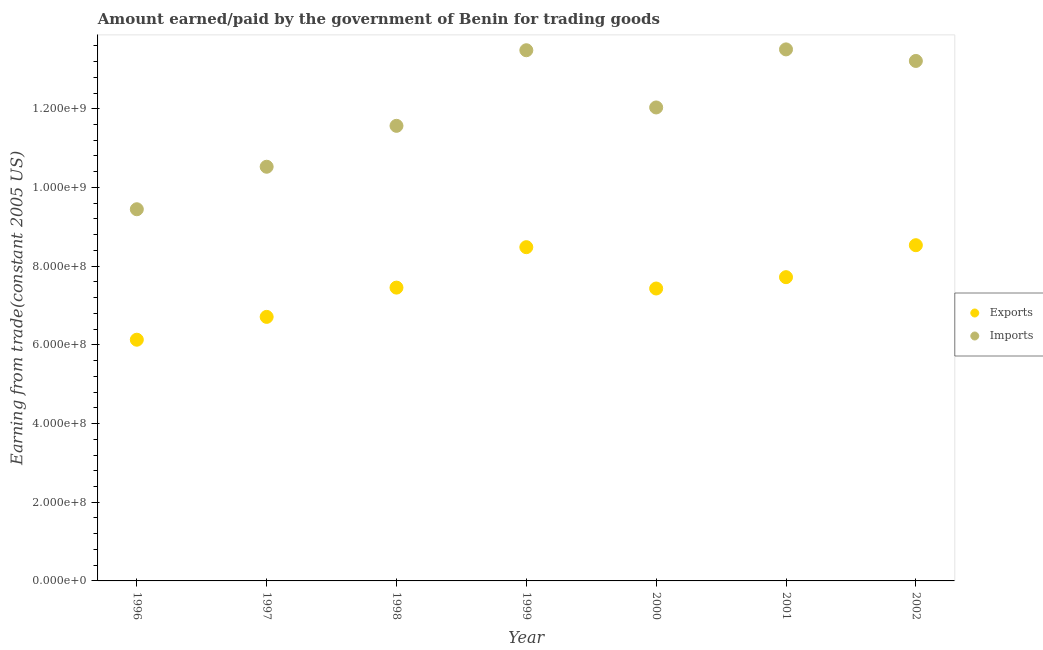How many different coloured dotlines are there?
Keep it short and to the point. 2. What is the amount earned from exports in 2000?
Ensure brevity in your answer.  7.43e+08. Across all years, what is the maximum amount earned from exports?
Provide a short and direct response. 8.53e+08. Across all years, what is the minimum amount paid for imports?
Your response must be concise. 9.45e+08. In which year was the amount earned from exports maximum?
Make the answer very short. 2002. In which year was the amount paid for imports minimum?
Keep it short and to the point. 1996. What is the total amount earned from exports in the graph?
Offer a terse response. 5.25e+09. What is the difference between the amount earned from exports in 2000 and that in 2002?
Ensure brevity in your answer.  -1.10e+08. What is the difference between the amount earned from exports in 2001 and the amount paid for imports in 2002?
Offer a very short reply. -5.50e+08. What is the average amount paid for imports per year?
Offer a very short reply. 1.20e+09. In the year 2001, what is the difference between the amount paid for imports and amount earned from exports?
Your answer should be very brief. 5.79e+08. What is the ratio of the amount paid for imports in 1996 to that in 2000?
Your response must be concise. 0.79. Is the difference between the amount paid for imports in 1996 and 2000 greater than the difference between the amount earned from exports in 1996 and 2000?
Give a very brief answer. No. What is the difference between the highest and the second highest amount paid for imports?
Ensure brevity in your answer.  2.15e+06. What is the difference between the highest and the lowest amount paid for imports?
Make the answer very short. 4.06e+08. How many dotlines are there?
Provide a short and direct response. 2. What is the difference between two consecutive major ticks on the Y-axis?
Your response must be concise. 2.00e+08. Are the values on the major ticks of Y-axis written in scientific E-notation?
Provide a short and direct response. Yes. Does the graph contain grids?
Offer a very short reply. No. How many legend labels are there?
Your response must be concise. 2. What is the title of the graph?
Give a very brief answer. Amount earned/paid by the government of Benin for trading goods. What is the label or title of the Y-axis?
Make the answer very short. Earning from trade(constant 2005 US). What is the Earning from trade(constant 2005 US) in Exports in 1996?
Give a very brief answer. 6.13e+08. What is the Earning from trade(constant 2005 US) in Imports in 1996?
Make the answer very short. 9.45e+08. What is the Earning from trade(constant 2005 US) of Exports in 1997?
Offer a very short reply. 6.71e+08. What is the Earning from trade(constant 2005 US) in Imports in 1997?
Make the answer very short. 1.05e+09. What is the Earning from trade(constant 2005 US) in Exports in 1998?
Ensure brevity in your answer.  7.45e+08. What is the Earning from trade(constant 2005 US) of Imports in 1998?
Your answer should be compact. 1.16e+09. What is the Earning from trade(constant 2005 US) in Exports in 1999?
Make the answer very short. 8.48e+08. What is the Earning from trade(constant 2005 US) in Imports in 1999?
Your response must be concise. 1.35e+09. What is the Earning from trade(constant 2005 US) in Exports in 2000?
Offer a very short reply. 7.43e+08. What is the Earning from trade(constant 2005 US) of Imports in 2000?
Your response must be concise. 1.20e+09. What is the Earning from trade(constant 2005 US) of Exports in 2001?
Keep it short and to the point. 7.72e+08. What is the Earning from trade(constant 2005 US) in Imports in 2001?
Give a very brief answer. 1.35e+09. What is the Earning from trade(constant 2005 US) in Exports in 2002?
Provide a succinct answer. 8.53e+08. What is the Earning from trade(constant 2005 US) in Imports in 2002?
Provide a succinct answer. 1.32e+09. Across all years, what is the maximum Earning from trade(constant 2005 US) in Exports?
Keep it short and to the point. 8.53e+08. Across all years, what is the maximum Earning from trade(constant 2005 US) in Imports?
Your response must be concise. 1.35e+09. Across all years, what is the minimum Earning from trade(constant 2005 US) of Exports?
Keep it short and to the point. 6.13e+08. Across all years, what is the minimum Earning from trade(constant 2005 US) of Imports?
Your answer should be compact. 9.45e+08. What is the total Earning from trade(constant 2005 US) of Exports in the graph?
Your answer should be compact. 5.25e+09. What is the total Earning from trade(constant 2005 US) in Imports in the graph?
Ensure brevity in your answer.  8.38e+09. What is the difference between the Earning from trade(constant 2005 US) in Exports in 1996 and that in 1997?
Your answer should be very brief. -5.80e+07. What is the difference between the Earning from trade(constant 2005 US) in Imports in 1996 and that in 1997?
Your response must be concise. -1.08e+08. What is the difference between the Earning from trade(constant 2005 US) in Exports in 1996 and that in 1998?
Keep it short and to the point. -1.32e+08. What is the difference between the Earning from trade(constant 2005 US) of Imports in 1996 and that in 1998?
Ensure brevity in your answer.  -2.12e+08. What is the difference between the Earning from trade(constant 2005 US) of Exports in 1996 and that in 1999?
Your answer should be very brief. -2.35e+08. What is the difference between the Earning from trade(constant 2005 US) in Imports in 1996 and that in 1999?
Make the answer very short. -4.04e+08. What is the difference between the Earning from trade(constant 2005 US) in Exports in 1996 and that in 2000?
Provide a succinct answer. -1.30e+08. What is the difference between the Earning from trade(constant 2005 US) in Imports in 1996 and that in 2000?
Your answer should be compact. -2.59e+08. What is the difference between the Earning from trade(constant 2005 US) in Exports in 1996 and that in 2001?
Your answer should be very brief. -1.59e+08. What is the difference between the Earning from trade(constant 2005 US) in Imports in 1996 and that in 2001?
Provide a succinct answer. -4.06e+08. What is the difference between the Earning from trade(constant 2005 US) of Exports in 1996 and that in 2002?
Offer a very short reply. -2.40e+08. What is the difference between the Earning from trade(constant 2005 US) in Imports in 1996 and that in 2002?
Provide a succinct answer. -3.77e+08. What is the difference between the Earning from trade(constant 2005 US) in Exports in 1997 and that in 1998?
Ensure brevity in your answer.  -7.44e+07. What is the difference between the Earning from trade(constant 2005 US) in Imports in 1997 and that in 1998?
Keep it short and to the point. -1.04e+08. What is the difference between the Earning from trade(constant 2005 US) of Exports in 1997 and that in 1999?
Offer a terse response. -1.77e+08. What is the difference between the Earning from trade(constant 2005 US) of Imports in 1997 and that in 1999?
Make the answer very short. -2.96e+08. What is the difference between the Earning from trade(constant 2005 US) of Exports in 1997 and that in 2000?
Provide a succinct answer. -7.21e+07. What is the difference between the Earning from trade(constant 2005 US) in Imports in 1997 and that in 2000?
Offer a terse response. -1.51e+08. What is the difference between the Earning from trade(constant 2005 US) in Exports in 1997 and that in 2001?
Make the answer very short. -1.01e+08. What is the difference between the Earning from trade(constant 2005 US) in Imports in 1997 and that in 2001?
Your answer should be very brief. -2.98e+08. What is the difference between the Earning from trade(constant 2005 US) in Exports in 1997 and that in 2002?
Your answer should be compact. -1.82e+08. What is the difference between the Earning from trade(constant 2005 US) in Imports in 1997 and that in 2002?
Offer a terse response. -2.69e+08. What is the difference between the Earning from trade(constant 2005 US) in Exports in 1998 and that in 1999?
Provide a short and direct response. -1.03e+08. What is the difference between the Earning from trade(constant 2005 US) of Imports in 1998 and that in 1999?
Make the answer very short. -1.92e+08. What is the difference between the Earning from trade(constant 2005 US) in Exports in 1998 and that in 2000?
Provide a short and direct response. 2.26e+06. What is the difference between the Earning from trade(constant 2005 US) of Imports in 1998 and that in 2000?
Ensure brevity in your answer.  -4.67e+07. What is the difference between the Earning from trade(constant 2005 US) in Exports in 1998 and that in 2001?
Ensure brevity in your answer.  -2.66e+07. What is the difference between the Earning from trade(constant 2005 US) of Imports in 1998 and that in 2001?
Keep it short and to the point. -1.94e+08. What is the difference between the Earning from trade(constant 2005 US) of Exports in 1998 and that in 2002?
Offer a very short reply. -1.08e+08. What is the difference between the Earning from trade(constant 2005 US) of Imports in 1998 and that in 2002?
Your answer should be very brief. -1.65e+08. What is the difference between the Earning from trade(constant 2005 US) of Exports in 1999 and that in 2000?
Provide a succinct answer. 1.05e+08. What is the difference between the Earning from trade(constant 2005 US) in Imports in 1999 and that in 2000?
Offer a terse response. 1.45e+08. What is the difference between the Earning from trade(constant 2005 US) in Exports in 1999 and that in 2001?
Offer a terse response. 7.62e+07. What is the difference between the Earning from trade(constant 2005 US) of Imports in 1999 and that in 2001?
Ensure brevity in your answer.  -2.15e+06. What is the difference between the Earning from trade(constant 2005 US) in Exports in 1999 and that in 2002?
Give a very brief answer. -5.01e+06. What is the difference between the Earning from trade(constant 2005 US) in Imports in 1999 and that in 2002?
Your response must be concise. 2.72e+07. What is the difference between the Earning from trade(constant 2005 US) in Exports in 2000 and that in 2001?
Your response must be concise. -2.88e+07. What is the difference between the Earning from trade(constant 2005 US) in Imports in 2000 and that in 2001?
Offer a very short reply. -1.48e+08. What is the difference between the Earning from trade(constant 2005 US) in Exports in 2000 and that in 2002?
Provide a succinct answer. -1.10e+08. What is the difference between the Earning from trade(constant 2005 US) of Imports in 2000 and that in 2002?
Your response must be concise. -1.18e+08. What is the difference between the Earning from trade(constant 2005 US) of Exports in 2001 and that in 2002?
Your response must be concise. -8.12e+07. What is the difference between the Earning from trade(constant 2005 US) of Imports in 2001 and that in 2002?
Your answer should be compact. 2.94e+07. What is the difference between the Earning from trade(constant 2005 US) of Exports in 1996 and the Earning from trade(constant 2005 US) of Imports in 1997?
Your answer should be very brief. -4.40e+08. What is the difference between the Earning from trade(constant 2005 US) in Exports in 1996 and the Earning from trade(constant 2005 US) in Imports in 1998?
Your answer should be very brief. -5.44e+08. What is the difference between the Earning from trade(constant 2005 US) in Exports in 1996 and the Earning from trade(constant 2005 US) in Imports in 1999?
Give a very brief answer. -7.36e+08. What is the difference between the Earning from trade(constant 2005 US) of Exports in 1996 and the Earning from trade(constant 2005 US) of Imports in 2000?
Keep it short and to the point. -5.90e+08. What is the difference between the Earning from trade(constant 2005 US) of Exports in 1996 and the Earning from trade(constant 2005 US) of Imports in 2001?
Make the answer very short. -7.38e+08. What is the difference between the Earning from trade(constant 2005 US) of Exports in 1996 and the Earning from trade(constant 2005 US) of Imports in 2002?
Provide a succinct answer. -7.08e+08. What is the difference between the Earning from trade(constant 2005 US) in Exports in 1997 and the Earning from trade(constant 2005 US) in Imports in 1998?
Your answer should be very brief. -4.86e+08. What is the difference between the Earning from trade(constant 2005 US) in Exports in 1997 and the Earning from trade(constant 2005 US) in Imports in 1999?
Keep it short and to the point. -6.78e+08. What is the difference between the Earning from trade(constant 2005 US) of Exports in 1997 and the Earning from trade(constant 2005 US) of Imports in 2000?
Provide a short and direct response. -5.32e+08. What is the difference between the Earning from trade(constant 2005 US) in Exports in 1997 and the Earning from trade(constant 2005 US) in Imports in 2001?
Offer a terse response. -6.80e+08. What is the difference between the Earning from trade(constant 2005 US) in Exports in 1997 and the Earning from trade(constant 2005 US) in Imports in 2002?
Make the answer very short. -6.50e+08. What is the difference between the Earning from trade(constant 2005 US) of Exports in 1998 and the Earning from trade(constant 2005 US) of Imports in 1999?
Make the answer very short. -6.03e+08. What is the difference between the Earning from trade(constant 2005 US) of Exports in 1998 and the Earning from trade(constant 2005 US) of Imports in 2000?
Your response must be concise. -4.58e+08. What is the difference between the Earning from trade(constant 2005 US) of Exports in 1998 and the Earning from trade(constant 2005 US) of Imports in 2001?
Your response must be concise. -6.05e+08. What is the difference between the Earning from trade(constant 2005 US) of Exports in 1998 and the Earning from trade(constant 2005 US) of Imports in 2002?
Offer a very short reply. -5.76e+08. What is the difference between the Earning from trade(constant 2005 US) in Exports in 1999 and the Earning from trade(constant 2005 US) in Imports in 2000?
Your response must be concise. -3.55e+08. What is the difference between the Earning from trade(constant 2005 US) of Exports in 1999 and the Earning from trade(constant 2005 US) of Imports in 2001?
Make the answer very short. -5.03e+08. What is the difference between the Earning from trade(constant 2005 US) in Exports in 1999 and the Earning from trade(constant 2005 US) in Imports in 2002?
Your answer should be very brief. -4.73e+08. What is the difference between the Earning from trade(constant 2005 US) of Exports in 2000 and the Earning from trade(constant 2005 US) of Imports in 2001?
Ensure brevity in your answer.  -6.08e+08. What is the difference between the Earning from trade(constant 2005 US) of Exports in 2000 and the Earning from trade(constant 2005 US) of Imports in 2002?
Make the answer very short. -5.78e+08. What is the difference between the Earning from trade(constant 2005 US) in Exports in 2001 and the Earning from trade(constant 2005 US) in Imports in 2002?
Give a very brief answer. -5.50e+08. What is the average Earning from trade(constant 2005 US) of Exports per year?
Ensure brevity in your answer.  7.49e+08. What is the average Earning from trade(constant 2005 US) of Imports per year?
Make the answer very short. 1.20e+09. In the year 1996, what is the difference between the Earning from trade(constant 2005 US) in Exports and Earning from trade(constant 2005 US) in Imports?
Offer a very short reply. -3.32e+08. In the year 1997, what is the difference between the Earning from trade(constant 2005 US) in Exports and Earning from trade(constant 2005 US) in Imports?
Keep it short and to the point. -3.82e+08. In the year 1998, what is the difference between the Earning from trade(constant 2005 US) of Exports and Earning from trade(constant 2005 US) of Imports?
Your answer should be very brief. -4.11e+08. In the year 1999, what is the difference between the Earning from trade(constant 2005 US) of Exports and Earning from trade(constant 2005 US) of Imports?
Ensure brevity in your answer.  -5.01e+08. In the year 2000, what is the difference between the Earning from trade(constant 2005 US) in Exports and Earning from trade(constant 2005 US) in Imports?
Ensure brevity in your answer.  -4.60e+08. In the year 2001, what is the difference between the Earning from trade(constant 2005 US) of Exports and Earning from trade(constant 2005 US) of Imports?
Your answer should be very brief. -5.79e+08. In the year 2002, what is the difference between the Earning from trade(constant 2005 US) of Exports and Earning from trade(constant 2005 US) of Imports?
Provide a short and direct response. -4.68e+08. What is the ratio of the Earning from trade(constant 2005 US) in Exports in 1996 to that in 1997?
Give a very brief answer. 0.91. What is the ratio of the Earning from trade(constant 2005 US) in Imports in 1996 to that in 1997?
Make the answer very short. 0.9. What is the ratio of the Earning from trade(constant 2005 US) in Exports in 1996 to that in 1998?
Your response must be concise. 0.82. What is the ratio of the Earning from trade(constant 2005 US) in Imports in 1996 to that in 1998?
Offer a terse response. 0.82. What is the ratio of the Earning from trade(constant 2005 US) of Exports in 1996 to that in 1999?
Offer a terse response. 0.72. What is the ratio of the Earning from trade(constant 2005 US) in Imports in 1996 to that in 1999?
Provide a short and direct response. 0.7. What is the ratio of the Earning from trade(constant 2005 US) in Exports in 1996 to that in 2000?
Make the answer very short. 0.82. What is the ratio of the Earning from trade(constant 2005 US) of Imports in 1996 to that in 2000?
Offer a terse response. 0.79. What is the ratio of the Earning from trade(constant 2005 US) of Exports in 1996 to that in 2001?
Provide a succinct answer. 0.79. What is the ratio of the Earning from trade(constant 2005 US) in Imports in 1996 to that in 2001?
Offer a very short reply. 0.7. What is the ratio of the Earning from trade(constant 2005 US) of Exports in 1996 to that in 2002?
Make the answer very short. 0.72. What is the ratio of the Earning from trade(constant 2005 US) of Imports in 1996 to that in 2002?
Your response must be concise. 0.71. What is the ratio of the Earning from trade(constant 2005 US) of Exports in 1997 to that in 1998?
Keep it short and to the point. 0.9. What is the ratio of the Earning from trade(constant 2005 US) in Imports in 1997 to that in 1998?
Give a very brief answer. 0.91. What is the ratio of the Earning from trade(constant 2005 US) of Exports in 1997 to that in 1999?
Offer a terse response. 0.79. What is the ratio of the Earning from trade(constant 2005 US) in Imports in 1997 to that in 1999?
Provide a short and direct response. 0.78. What is the ratio of the Earning from trade(constant 2005 US) of Exports in 1997 to that in 2000?
Provide a short and direct response. 0.9. What is the ratio of the Earning from trade(constant 2005 US) of Imports in 1997 to that in 2000?
Offer a terse response. 0.87. What is the ratio of the Earning from trade(constant 2005 US) of Exports in 1997 to that in 2001?
Your response must be concise. 0.87. What is the ratio of the Earning from trade(constant 2005 US) of Imports in 1997 to that in 2001?
Provide a short and direct response. 0.78. What is the ratio of the Earning from trade(constant 2005 US) in Exports in 1997 to that in 2002?
Ensure brevity in your answer.  0.79. What is the ratio of the Earning from trade(constant 2005 US) of Imports in 1997 to that in 2002?
Your answer should be very brief. 0.8. What is the ratio of the Earning from trade(constant 2005 US) of Exports in 1998 to that in 1999?
Make the answer very short. 0.88. What is the ratio of the Earning from trade(constant 2005 US) of Imports in 1998 to that in 1999?
Make the answer very short. 0.86. What is the ratio of the Earning from trade(constant 2005 US) of Exports in 1998 to that in 2000?
Offer a very short reply. 1. What is the ratio of the Earning from trade(constant 2005 US) of Imports in 1998 to that in 2000?
Your answer should be very brief. 0.96. What is the ratio of the Earning from trade(constant 2005 US) of Exports in 1998 to that in 2001?
Provide a succinct answer. 0.97. What is the ratio of the Earning from trade(constant 2005 US) in Imports in 1998 to that in 2001?
Your answer should be compact. 0.86. What is the ratio of the Earning from trade(constant 2005 US) of Exports in 1998 to that in 2002?
Your response must be concise. 0.87. What is the ratio of the Earning from trade(constant 2005 US) in Imports in 1998 to that in 2002?
Offer a very short reply. 0.88. What is the ratio of the Earning from trade(constant 2005 US) of Exports in 1999 to that in 2000?
Keep it short and to the point. 1.14. What is the ratio of the Earning from trade(constant 2005 US) of Imports in 1999 to that in 2000?
Provide a succinct answer. 1.12. What is the ratio of the Earning from trade(constant 2005 US) of Exports in 1999 to that in 2001?
Offer a terse response. 1.1. What is the ratio of the Earning from trade(constant 2005 US) of Imports in 1999 to that in 2002?
Your answer should be compact. 1.02. What is the ratio of the Earning from trade(constant 2005 US) in Exports in 2000 to that in 2001?
Give a very brief answer. 0.96. What is the ratio of the Earning from trade(constant 2005 US) in Imports in 2000 to that in 2001?
Keep it short and to the point. 0.89. What is the ratio of the Earning from trade(constant 2005 US) of Exports in 2000 to that in 2002?
Offer a terse response. 0.87. What is the ratio of the Earning from trade(constant 2005 US) in Imports in 2000 to that in 2002?
Provide a succinct answer. 0.91. What is the ratio of the Earning from trade(constant 2005 US) of Exports in 2001 to that in 2002?
Your answer should be very brief. 0.9. What is the ratio of the Earning from trade(constant 2005 US) of Imports in 2001 to that in 2002?
Make the answer very short. 1.02. What is the difference between the highest and the second highest Earning from trade(constant 2005 US) in Exports?
Offer a terse response. 5.01e+06. What is the difference between the highest and the second highest Earning from trade(constant 2005 US) in Imports?
Ensure brevity in your answer.  2.15e+06. What is the difference between the highest and the lowest Earning from trade(constant 2005 US) of Exports?
Your answer should be compact. 2.40e+08. What is the difference between the highest and the lowest Earning from trade(constant 2005 US) of Imports?
Give a very brief answer. 4.06e+08. 